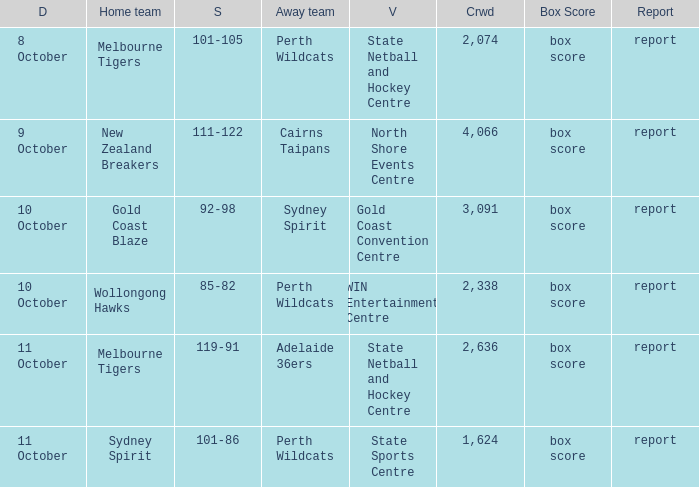What was the crowd size for the game with a score of 101-105? 2074.0. 